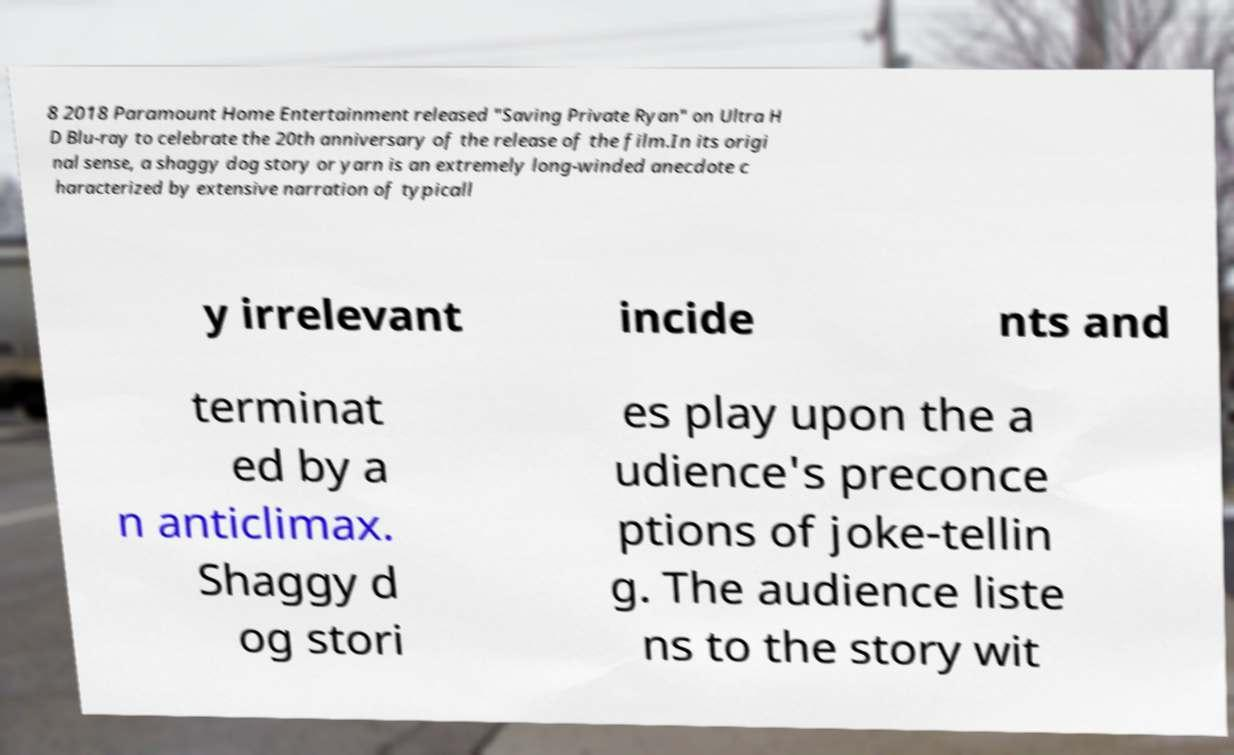Can you read and provide the text displayed in the image?This photo seems to have some interesting text. Can you extract and type it out for me? 8 2018 Paramount Home Entertainment released "Saving Private Ryan" on Ultra H D Blu-ray to celebrate the 20th anniversary of the release of the film.In its origi nal sense, a shaggy dog story or yarn is an extremely long-winded anecdote c haracterized by extensive narration of typicall y irrelevant incide nts and terminat ed by a n anticlimax. Shaggy d og stori es play upon the a udience's preconce ptions of joke-tellin g. The audience liste ns to the story wit 